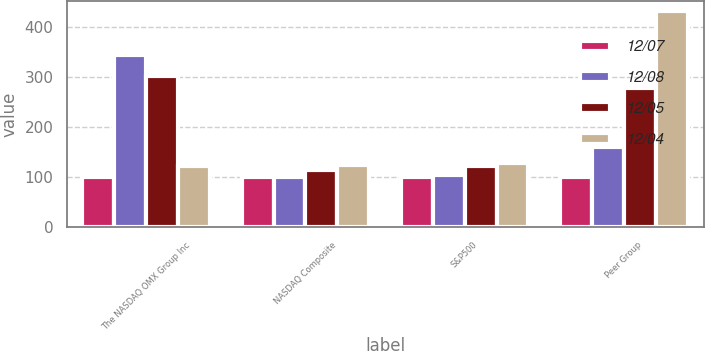Convert chart. <chart><loc_0><loc_0><loc_500><loc_500><stacked_bar_chart><ecel><fcel>The NASDAQ OMX Group Inc<fcel>NASDAQ Composite<fcel>S&P500<fcel>Peer Group<nl><fcel>12/07<fcel>100<fcel>100<fcel>100<fcel>100<nl><fcel>12/08<fcel>344.9<fcel>101.33<fcel>104.91<fcel>159.42<nl><fcel>12/05<fcel>301.86<fcel>114.01<fcel>121.48<fcel>277.66<nl><fcel>12/04<fcel>121.48<fcel>123.71<fcel>128.16<fcel>431.54<nl></chart> 